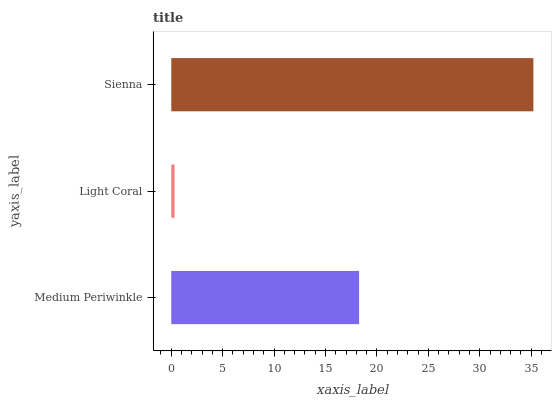Is Light Coral the minimum?
Answer yes or no. Yes. Is Sienna the maximum?
Answer yes or no. Yes. Is Sienna the minimum?
Answer yes or no. No. Is Light Coral the maximum?
Answer yes or no. No. Is Sienna greater than Light Coral?
Answer yes or no. Yes. Is Light Coral less than Sienna?
Answer yes or no. Yes. Is Light Coral greater than Sienna?
Answer yes or no. No. Is Sienna less than Light Coral?
Answer yes or no. No. Is Medium Periwinkle the high median?
Answer yes or no. Yes. Is Medium Periwinkle the low median?
Answer yes or no. Yes. Is Light Coral the high median?
Answer yes or no. No. Is Light Coral the low median?
Answer yes or no. No. 